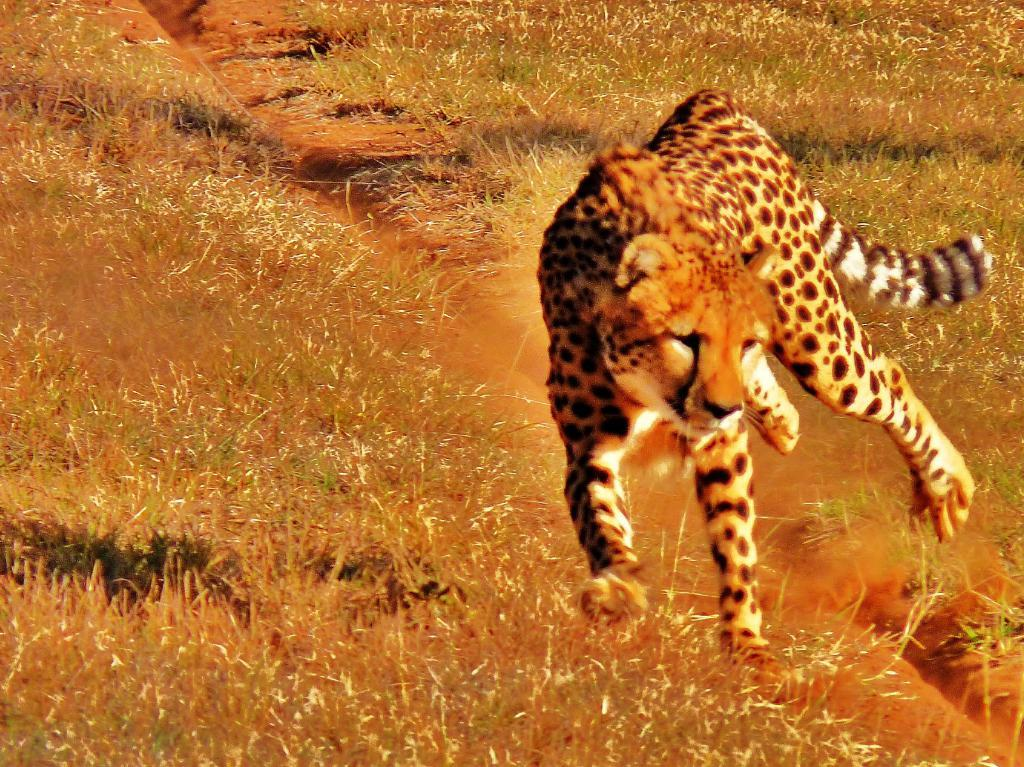What animal is the main subject of the image? There is a cheetah in the image. What is the cheetah doing in the image? The cheetah is running in the image. What type of terrain is the cheetah running on? The cheetah is on the grass in the image. What type of pollution can be seen in the image? There is no pollution present in the image; it features a cheetah running on grass. How many dogs are visible in the image? There are no dogs present in the image; it features a cheetah running on grass. 